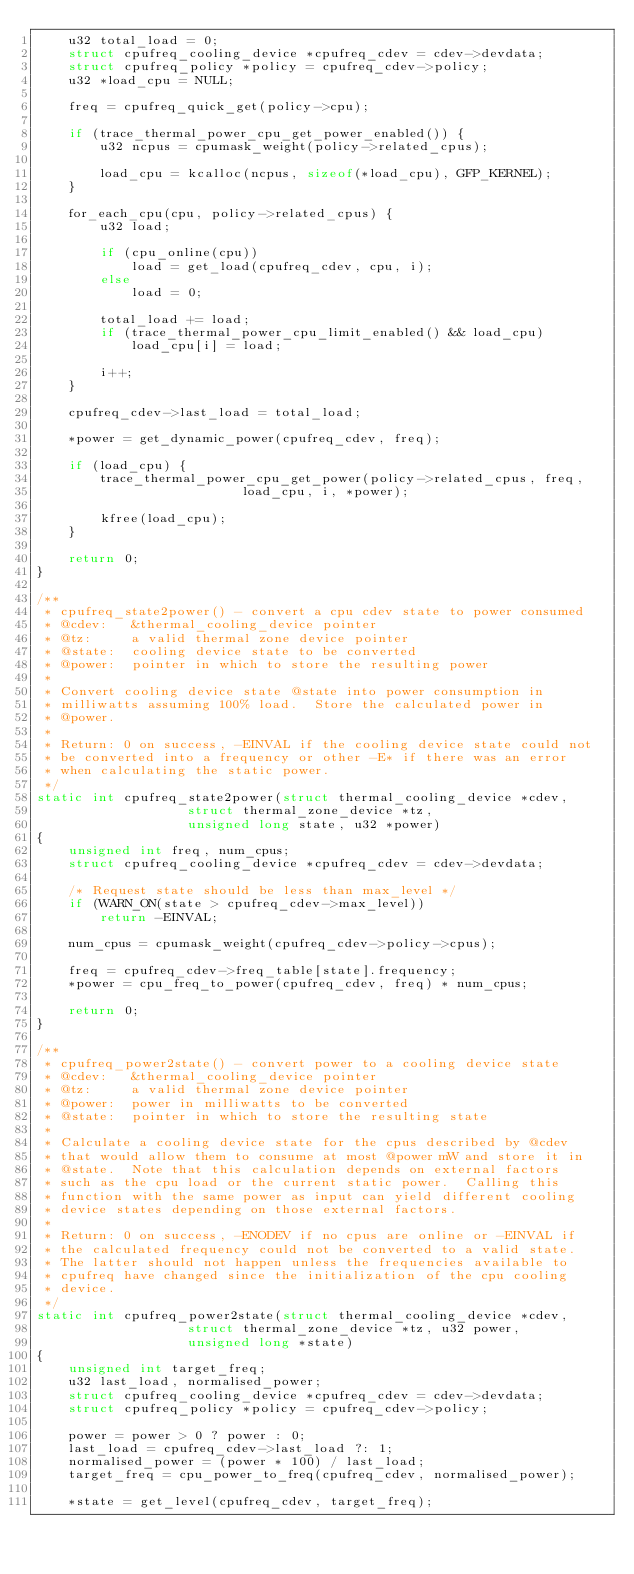<code> <loc_0><loc_0><loc_500><loc_500><_C_>	u32 total_load = 0;
	struct cpufreq_cooling_device *cpufreq_cdev = cdev->devdata;
	struct cpufreq_policy *policy = cpufreq_cdev->policy;
	u32 *load_cpu = NULL;

	freq = cpufreq_quick_get(policy->cpu);

	if (trace_thermal_power_cpu_get_power_enabled()) {
		u32 ncpus = cpumask_weight(policy->related_cpus);

		load_cpu = kcalloc(ncpus, sizeof(*load_cpu), GFP_KERNEL);
	}

	for_each_cpu(cpu, policy->related_cpus) {
		u32 load;

		if (cpu_online(cpu))
			load = get_load(cpufreq_cdev, cpu, i);
		else
			load = 0;

		total_load += load;
		if (trace_thermal_power_cpu_limit_enabled() && load_cpu)
			load_cpu[i] = load;

		i++;
	}

	cpufreq_cdev->last_load = total_load;

	*power = get_dynamic_power(cpufreq_cdev, freq);

	if (load_cpu) {
		trace_thermal_power_cpu_get_power(policy->related_cpus, freq,
						  load_cpu, i, *power);

		kfree(load_cpu);
	}

	return 0;
}

/**
 * cpufreq_state2power() - convert a cpu cdev state to power consumed
 * @cdev:	&thermal_cooling_device pointer
 * @tz:		a valid thermal zone device pointer
 * @state:	cooling device state to be converted
 * @power:	pointer in which to store the resulting power
 *
 * Convert cooling device state @state into power consumption in
 * milliwatts assuming 100% load.  Store the calculated power in
 * @power.
 *
 * Return: 0 on success, -EINVAL if the cooling device state could not
 * be converted into a frequency or other -E* if there was an error
 * when calculating the static power.
 */
static int cpufreq_state2power(struct thermal_cooling_device *cdev,
			       struct thermal_zone_device *tz,
			       unsigned long state, u32 *power)
{
	unsigned int freq, num_cpus;
	struct cpufreq_cooling_device *cpufreq_cdev = cdev->devdata;

	/* Request state should be less than max_level */
	if (WARN_ON(state > cpufreq_cdev->max_level))
		return -EINVAL;

	num_cpus = cpumask_weight(cpufreq_cdev->policy->cpus);

	freq = cpufreq_cdev->freq_table[state].frequency;
	*power = cpu_freq_to_power(cpufreq_cdev, freq) * num_cpus;

	return 0;
}

/**
 * cpufreq_power2state() - convert power to a cooling device state
 * @cdev:	&thermal_cooling_device pointer
 * @tz:		a valid thermal zone device pointer
 * @power:	power in milliwatts to be converted
 * @state:	pointer in which to store the resulting state
 *
 * Calculate a cooling device state for the cpus described by @cdev
 * that would allow them to consume at most @power mW and store it in
 * @state.  Note that this calculation depends on external factors
 * such as the cpu load or the current static power.  Calling this
 * function with the same power as input can yield different cooling
 * device states depending on those external factors.
 *
 * Return: 0 on success, -ENODEV if no cpus are online or -EINVAL if
 * the calculated frequency could not be converted to a valid state.
 * The latter should not happen unless the frequencies available to
 * cpufreq have changed since the initialization of the cpu cooling
 * device.
 */
static int cpufreq_power2state(struct thermal_cooling_device *cdev,
			       struct thermal_zone_device *tz, u32 power,
			       unsigned long *state)
{
	unsigned int target_freq;
	u32 last_load, normalised_power;
	struct cpufreq_cooling_device *cpufreq_cdev = cdev->devdata;
	struct cpufreq_policy *policy = cpufreq_cdev->policy;

	power = power > 0 ? power : 0;
	last_load = cpufreq_cdev->last_load ?: 1;
	normalised_power = (power * 100) / last_load;
	target_freq = cpu_power_to_freq(cpufreq_cdev, normalised_power);

	*state = get_level(cpufreq_cdev, target_freq);</code> 